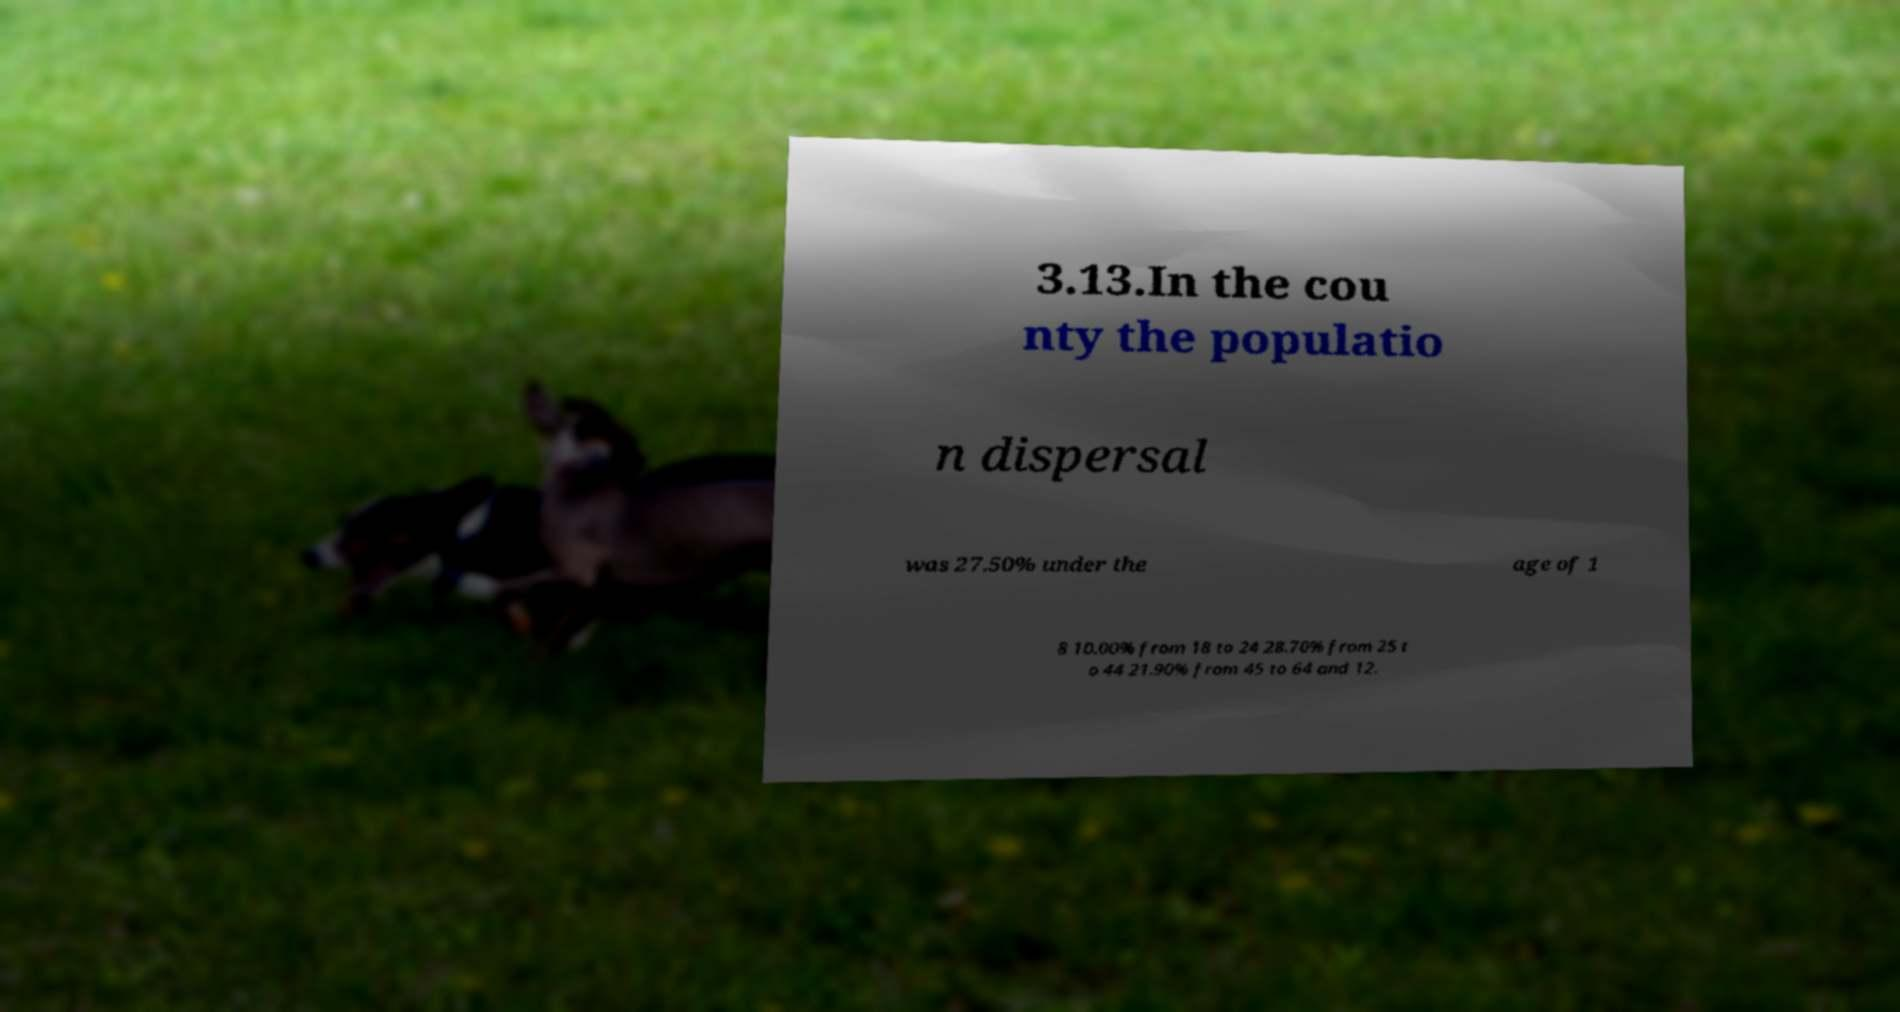Please identify and transcribe the text found in this image. 3.13.In the cou nty the populatio n dispersal was 27.50% under the age of 1 8 10.00% from 18 to 24 28.70% from 25 t o 44 21.90% from 45 to 64 and 12. 